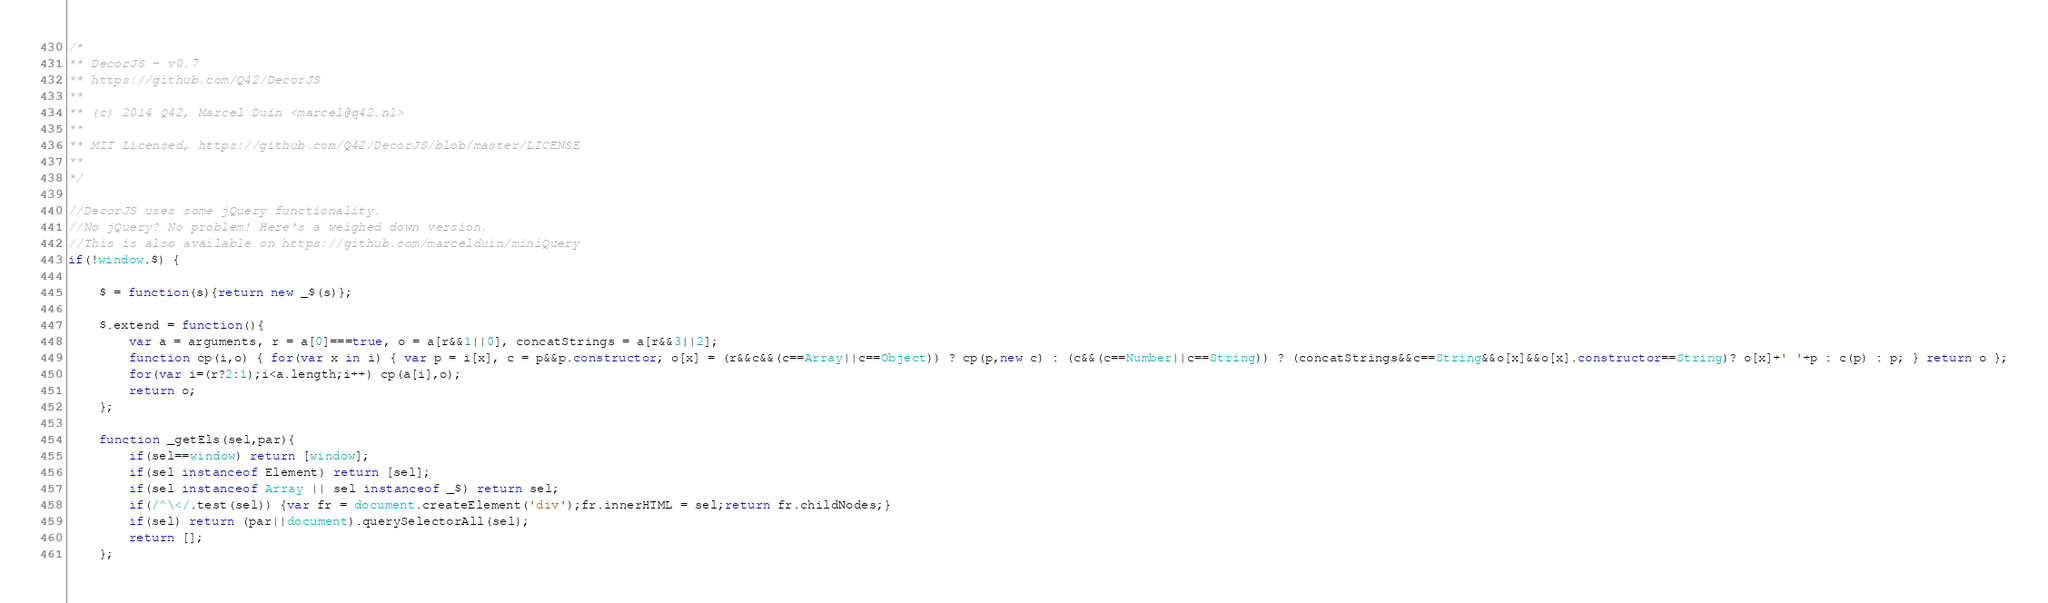<code> <loc_0><loc_0><loc_500><loc_500><_JavaScript_>/*
** DecorJS - v0.7
** https://github.com/Q42/DecorJS
**
** (c) 2014 Q42, Marcel Duin <marcel@q42.nl>
**
** MIT Licensed, https://github.com/Q42/DecorJS/blob/master/LICENSE
**
*/

//DecorJS uses some jQuery functionality.
//No jQuery? No problem! Here's a weighed down version.
//This is also available on https://github.com/marcelduin/miniQuery
if(!window.$) {

	$ = function(s){return new _$(s)};

	$.extend = function(){
		var a = arguments, r = a[0]===true, o = a[r&&1||0], concatStrings = a[r&&3||2];
		function cp(i,o) { for(var x in i) { var p = i[x], c = p&&p.constructor; o[x] = (r&&c&&(c==Array||c==Object)) ? cp(p,new c) : (c&&(c==Number||c==String)) ? (concatStrings&&c==String&&o[x]&&o[x].constructor==String)? o[x]+' '+p : c(p) : p; } return o };
		for(var i=(r?2:1);i<a.length;i++) cp(a[i],o);
		return o;
	};

	function _getEls(sel,par){
		if(sel==window) return [window];
		if(sel instanceof Element) return [sel];
		if(sel instanceof Array || sel instanceof _$) return sel;
		if(/^\</.test(sel)) {var fr = document.createElement('div');fr.innerHTML = sel;return fr.childNodes;}
		if(sel) return (par||document).querySelectorAll(sel);
		return [];
	};
</code> 